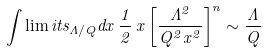<formula> <loc_0><loc_0><loc_500><loc_500>\int \lim i t s _ { \Lambda / Q } d x \, \frac { 1 } { 2 } \, x \left [ \frac { \Lambda ^ { 2 } } { Q ^ { 2 } x ^ { 2 } } \right ] ^ { n } \sim \frac { \Lambda } { Q }</formula> 